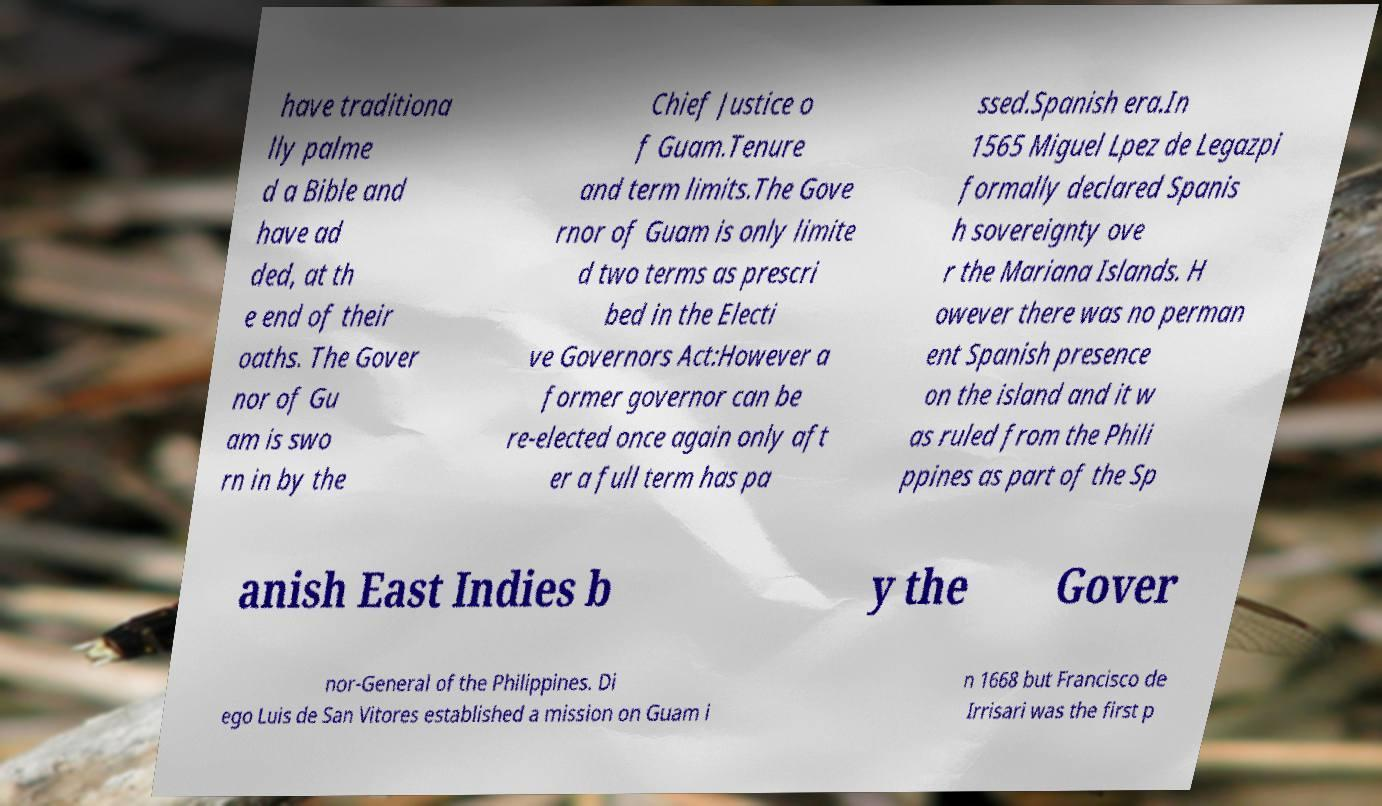Could you assist in decoding the text presented in this image and type it out clearly? have traditiona lly palme d a Bible and have ad ded, at th e end of their oaths. The Gover nor of Gu am is swo rn in by the Chief Justice o f Guam.Tenure and term limits.The Gove rnor of Guam is only limite d two terms as prescri bed in the Electi ve Governors Act:However a former governor can be re-elected once again only aft er a full term has pa ssed.Spanish era.In 1565 Miguel Lpez de Legazpi formally declared Spanis h sovereignty ove r the Mariana Islands. H owever there was no perman ent Spanish presence on the island and it w as ruled from the Phili ppines as part of the Sp anish East Indies b y the Gover nor-General of the Philippines. Di ego Luis de San Vitores established a mission on Guam i n 1668 but Francisco de Irrisari was the first p 